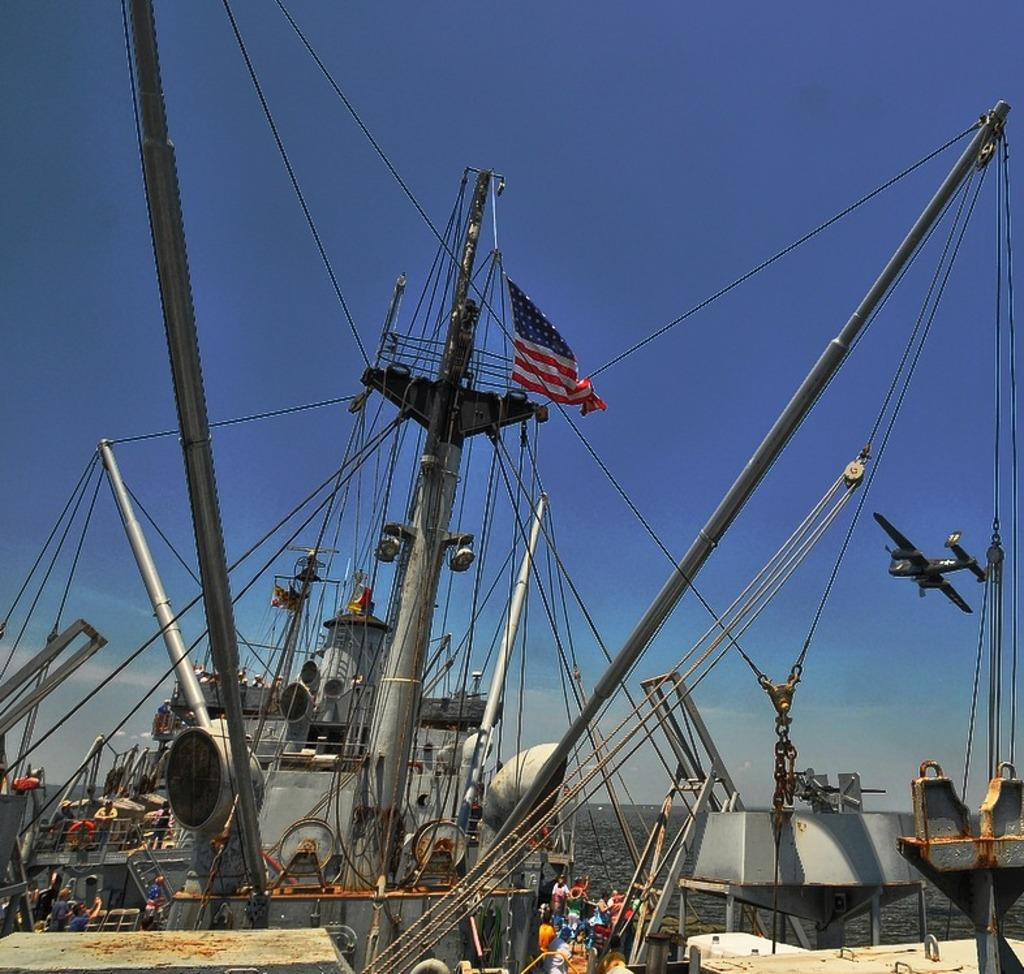What is the main subject of the picture? The main subject of the picture is a ship. What specific features can be seen on the ship? The ship has poles and wires. Is there any symbol or emblem on the ship? Yes, there is a flag on the ship. What can be seen in the background of the picture? The sky is visible in the background of the picture. What type of hydrant can be seen on the ship in the image? There is no hydrant present on the ship in the image. How does the ship's society function in the image? The image does not provide information about the ship's society or how it functions. What type of trousers are the crew members wearing in the image? The image does not show any crew members or their clothing, so it cannot be determined what type of trousers they might be wearing. 